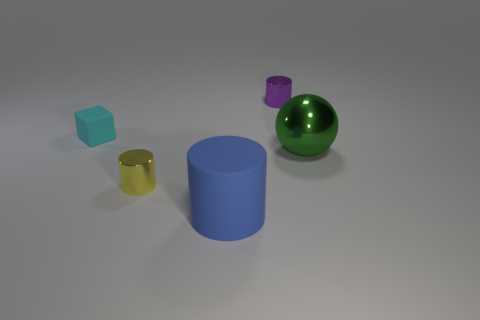What number of tiny cyan objects are on the right side of the big matte cylinder?
Give a very brief answer. 0. What number of things are right of the big blue thing and behind the green shiny object?
Ensure brevity in your answer.  1. What is the shape of the small cyan object that is made of the same material as the big blue thing?
Provide a succinct answer. Cube. Do the rubber thing that is on the right side of the tiny yellow thing and the thing to the right of the purple metallic object have the same size?
Keep it short and to the point. Yes. There is a matte object that is in front of the cyan matte cube; what color is it?
Your response must be concise. Blue. There is a object right of the small cylinder that is behind the big green ball; what is it made of?
Give a very brief answer. Metal. There is a large green shiny object; what shape is it?
Offer a very short reply. Sphere. What material is the blue thing that is the same shape as the tiny purple shiny object?
Provide a succinct answer. Rubber. What number of other rubber blocks are the same size as the matte block?
Make the answer very short. 0. Is there a thing to the left of the metallic thing on the left side of the blue matte cylinder?
Provide a short and direct response. Yes. 